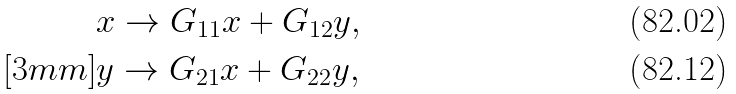Convert formula to latex. <formula><loc_0><loc_0><loc_500><loc_500>& x \to G _ { 1 1 } x + G _ { 1 2 } y , \\ [ 3 m m ] & y \to G _ { 2 1 } x + G _ { 2 2 } y ,</formula> 